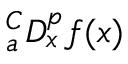<formula> <loc_0><loc_0><loc_500><loc_500>{ } _ { a } ^ { C } D _ { x } ^ { p } f ( x )</formula> 